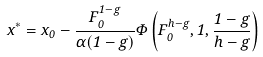<formula> <loc_0><loc_0><loc_500><loc_500>x ^ { \ast } = x _ { 0 } - \frac { F _ { 0 } ^ { 1 - g } } { \alpha ( 1 - g ) } \Phi \left ( F _ { 0 } ^ { h - g } , 1 , \frac { 1 - g } { h - g } \right )</formula> 